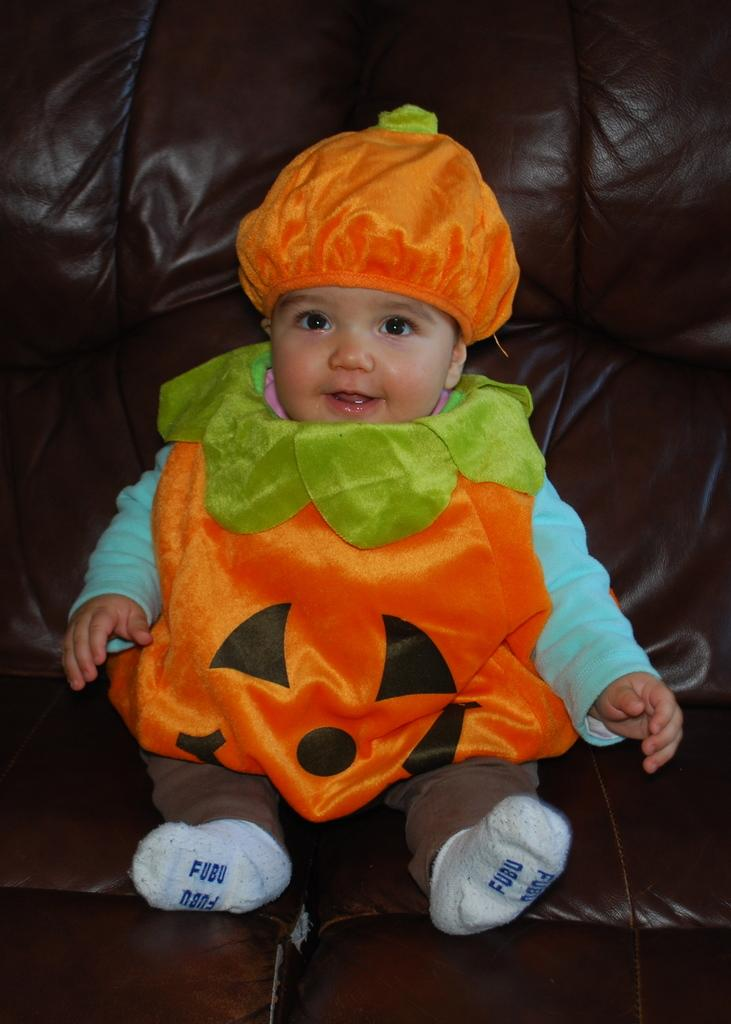What is the main subject of the image? The main subject of the image is a small boy. How is the boy dressed in the image? The boy is wearing an orange color pumpkin dress and a cap. What is the boy doing in the image? The boy is sitting on a brown leather sofa, smiling, and giving a pose to the camera. What type of beef is the boy eating in the image? There is no beef present in the image; the boy is wearing a pumpkin dress and posing for the camera. What kind of wine is the boy holding in the image? There is no wine present in the image; the boy is wearing a pumpkin dress and posing for the camera. 